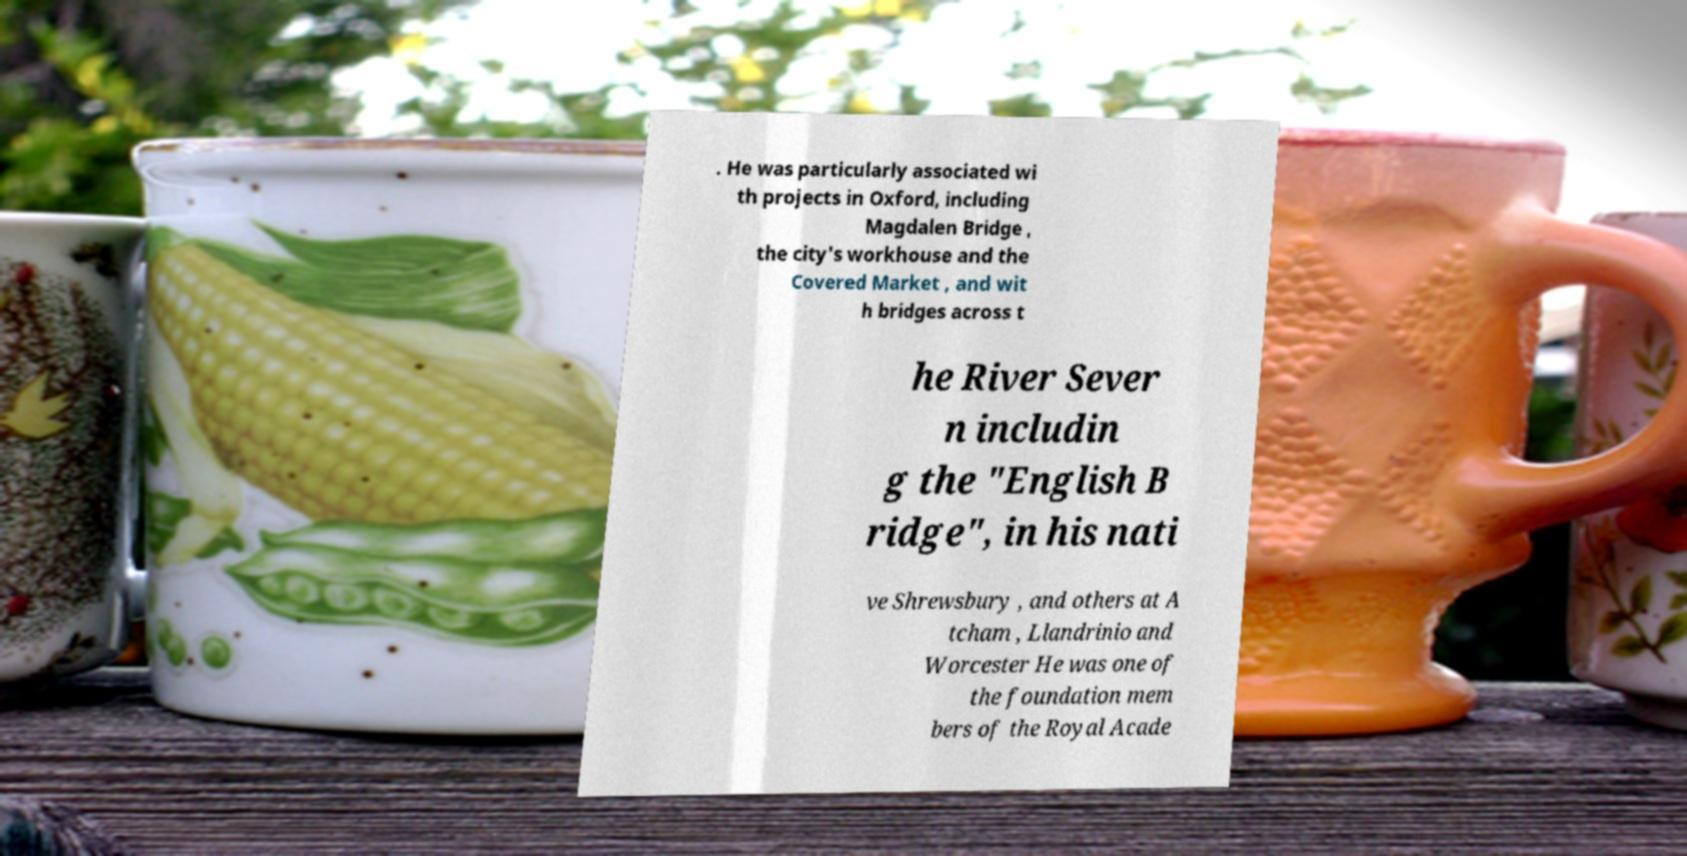I need the written content from this picture converted into text. Can you do that? . He was particularly associated wi th projects in Oxford, including Magdalen Bridge , the city's workhouse and the Covered Market , and wit h bridges across t he River Sever n includin g the "English B ridge", in his nati ve Shrewsbury , and others at A tcham , Llandrinio and Worcester He was one of the foundation mem bers of the Royal Acade 